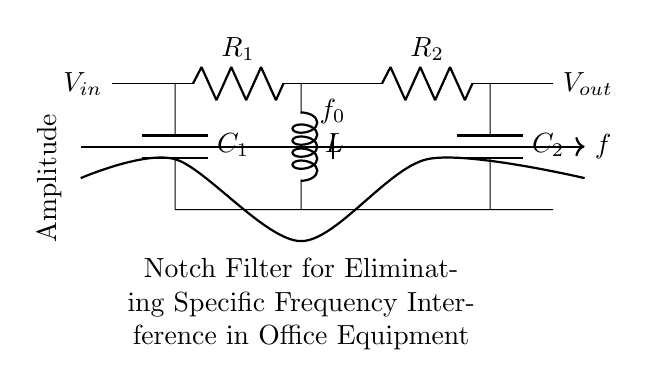What is the input voltage of the circuit? The input voltage is represented by the symbol V_in, which is shown on the left side of the circuit diagram. This indicates where the voltage is applied to the circuit.
Answer: V_in What are the values of R1 and R2? The circuit diagram labels R1 and R2, but it does not provide specific numerical values. Therefore, they cannot be determined directly from the diagram itself.
Answer: Not specified What is the role of the inductor in this circuit? The inductor (L) in the circuit acts to filter out a specific frequency of interference. It is part of the notch filter configuration designed to eliminate frequency interference.
Answer: Filter interference At what point in the frequency response is the output voltage observed? The output voltage (V_out) is observed at the right end of the circuit diagram, indicating where the filtered signal is taken from the circuit.
Answer: At the right end What type of filter is represented in the circuit? This circuit represents a notch filter, which is specifically designed to eliminate a narrow band of frequencies while allowing others to pass through.
Answer: Notch filter What does the term f_0 represent in this circuit? The term f_0 signifies the notch frequency, which is the specific frequency that the filter attenuates or eliminates in the circuit. It is a crucial parameter for the operation of the notch filter.
Answer: Notch frequency 